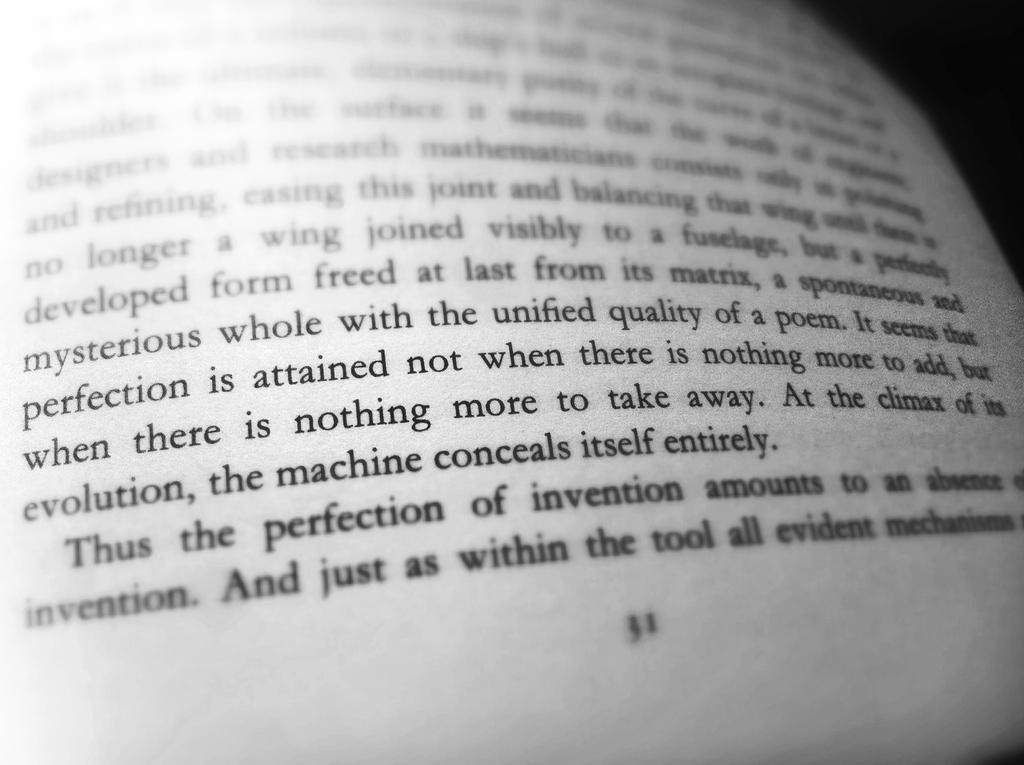At what point does the machine conceal itself?
Provide a short and direct response. At the climax of its evolution. 